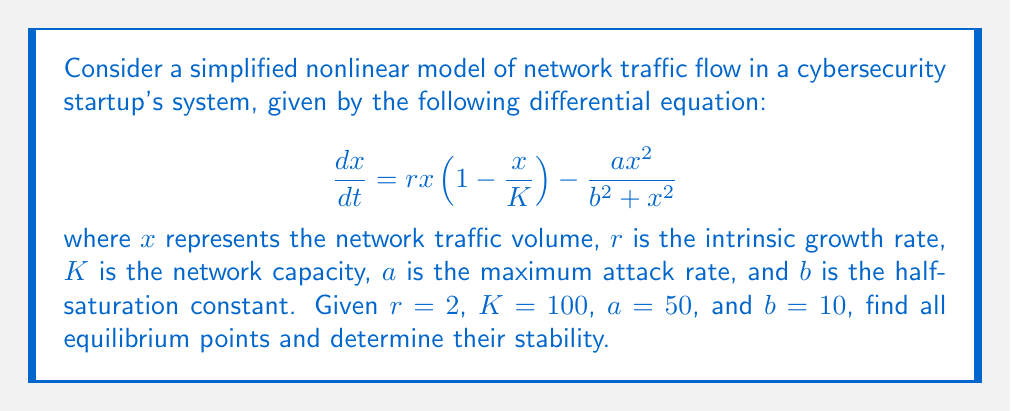Can you answer this question? 1) To find equilibrium points, set $\frac{dx}{dt} = 0$:

   $$0 = 2x(1-\frac{x}{100}) - \frac{50x^2}{100+x^2}$$

2) Multiply both sides by $(100+x^2)$:

   $$0 = 2x(1-\frac{x}{100})(100+x^2) - 50x^2$$

3) Expand:

   $$0 = 200x+2x^3-2x^2-\frac{2x^4}{100}-50x^2$$

4) Simplify:

   $$0 = 200x-52x^2+2x^3-0.02x^4$$

5) Factorize:

   $$x(200-52x+2x^2-0.02x^3) = 0$$

6) Solve. Clearly, $x=0$ is one solution. For the other factor, we can use numerical methods or graphing to find that $x \approx 96.8$ is another solution.

7) To determine stability, we calculate the derivative of $\frac{dx}{dt}$ with respect to $x$:

   $$\frac{d}{dx}(\frac{dx}{dt}) = 2(1-\frac{x}{50}) - \frac{2x}{50} - \frac{50x(b^2-x^2)}{(b^2+x^2)^2}$$

8) Evaluate at $x=0$:

   $$\frac{d}{dx}(\frac{dx}{dt})|_{x=0} = 2 > 0$$

   Therefore, $x=0$ is an unstable equilibrium point.

9) Evaluate at $x=96.8$:

   $$\frac{d}{dx}(\frac{dx}{dt})|_{x=96.8} \approx -1.91 < 0$$

   Therefore, $x=96.8$ is a stable equilibrium point.
Answer: Two equilibrium points: $x=0$ (unstable) and $x\approx96.8$ (stable) 